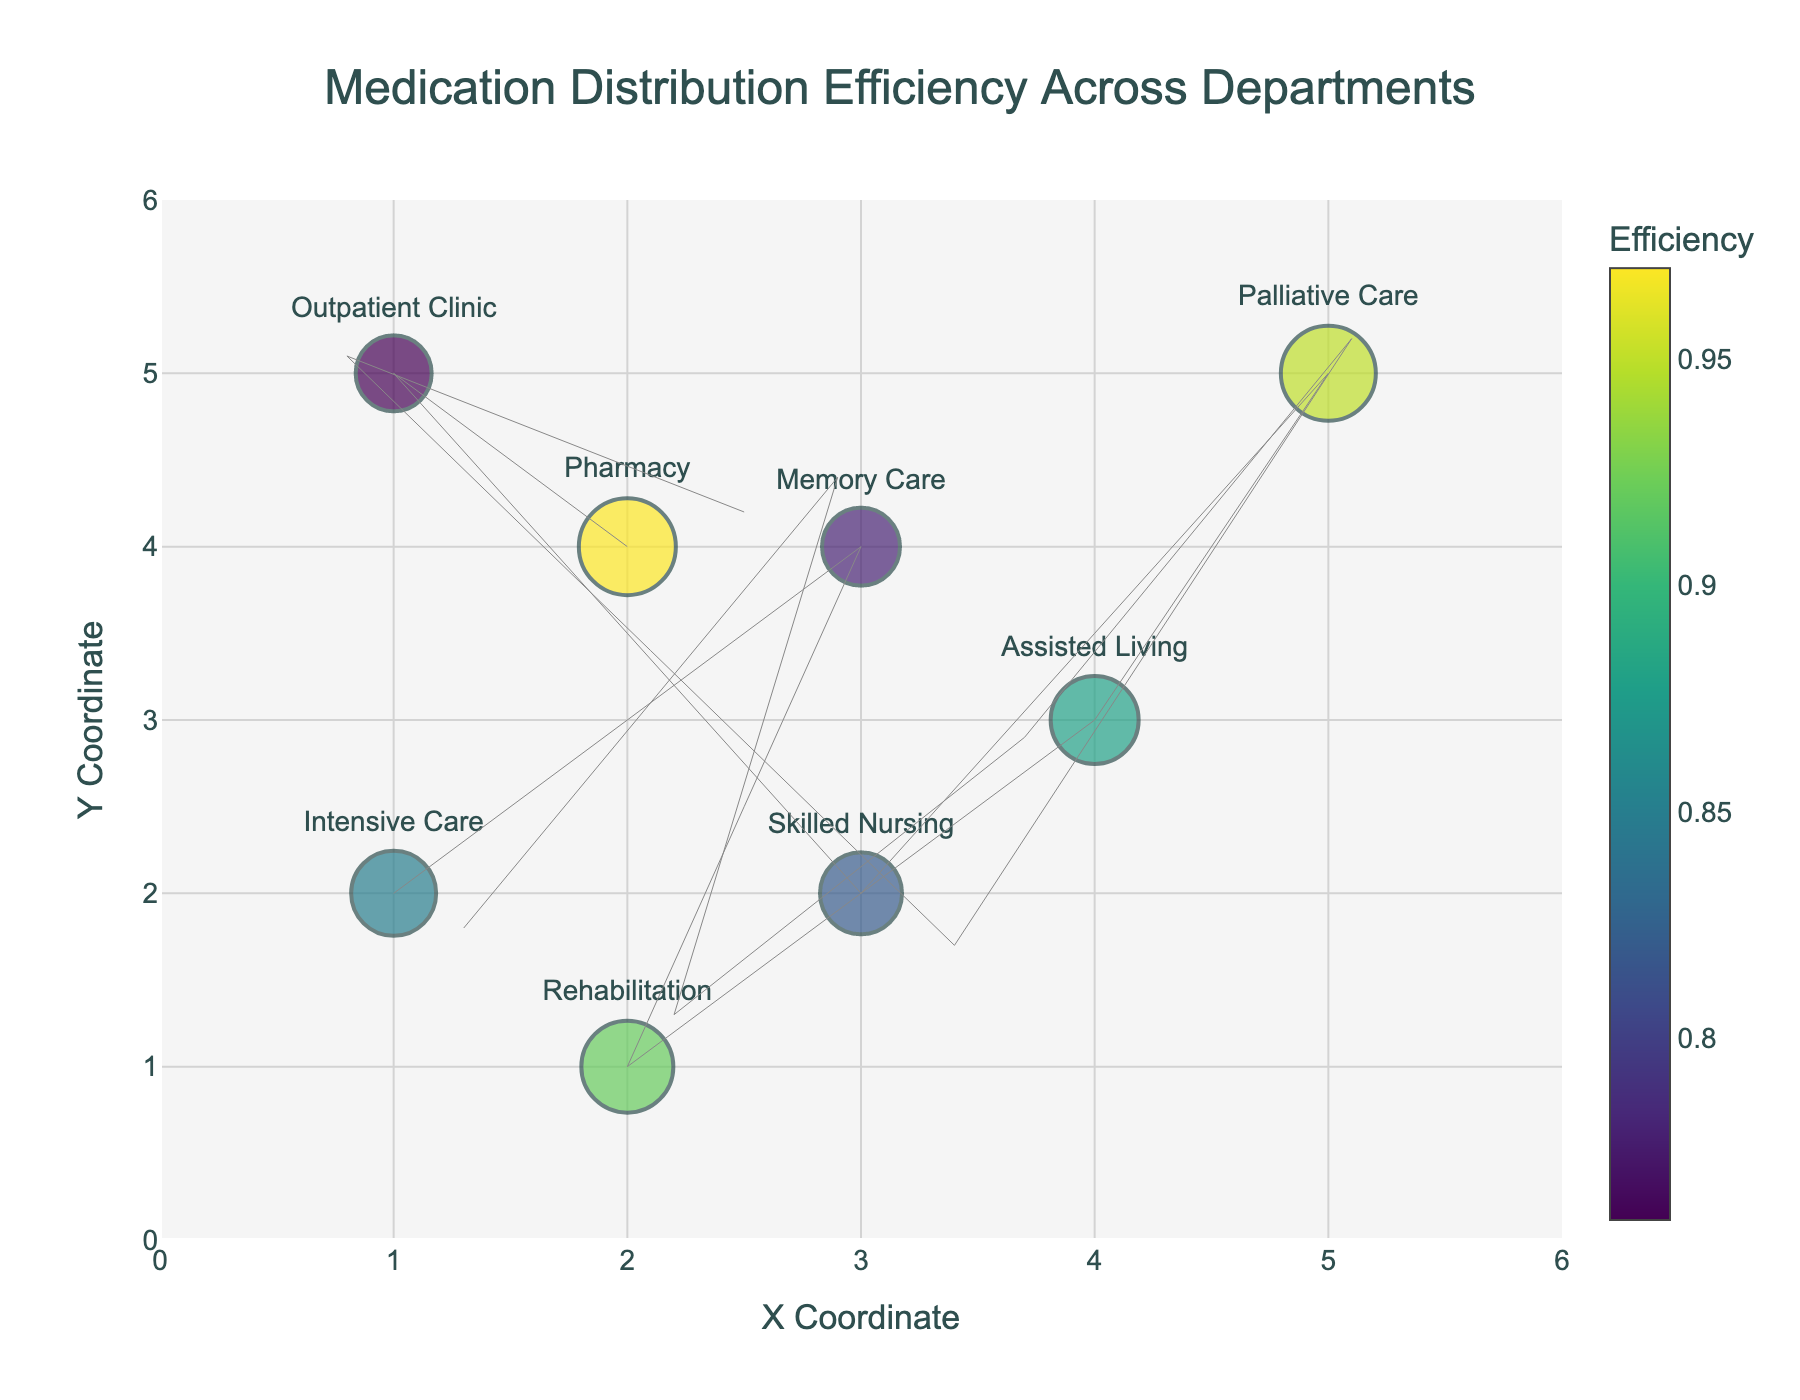What is the title of the plot? The title is located at the top of the plot. It reads "Medication Distribution Efficiency Across Departments."
Answer: Medication Distribution Efficiency Across Departments How many departments are shown in the plot? Counting the number of data points (markers) on the plot, we see there are 8 different departments.
Answer: 8 Which department has the highest medication distribution efficiency? By examining the color intensity and size of the markers representing each department, the Pharmacy department, with the darkest color and largest marker, shows the highest efficiency of 0.97.
Answer: Pharmacy What are the X and Y coordinates for the Rehabilitation department? By looking at the position of the Rehabilitation marker on the plot, you can see it is placed at the coordinates (2, 1).
Answer: (2, 1) Which department shows a movement direction with the least change in the X coordinate? Comparing the arrow lengths in the X direction for all departments, Memory Care has the smallest change in X direction (-0.1).
Answer: Memory Care What is the average medication distribution efficiency of the Intensive Care and Assisted Living departments? The efficiencies are 0.85 for Intensive Care and 0.88 for Assisted Living. The average is calculated as (0.85 + 0.88) / 2 = 0.865.
Answer: 0.865 Which department has the largest negative change in the Y direction from its original coordinates? Skimming through the directions provided, the Intensive Care department has the largest negative change of -0.2 in Y direction.
Answer: Intensive Care Which department's arrow points the closest to a vertical direction? By examining the angle of the arrows with respect to the vertical axis, Memory Care has a direction vector close to vertical with a small X component (-0.1) and larger Y component (0.4).
Answer: Memory Care Between Intensive Care and Outpatient Clinic, which department has a lower efficiency? The efficiencies are given as 0.85 for Intensive Care and 0.76 for Outpatient Clinic. Outpatient Clinic has the lower efficiency.
Answer: Outpatient Clinic 